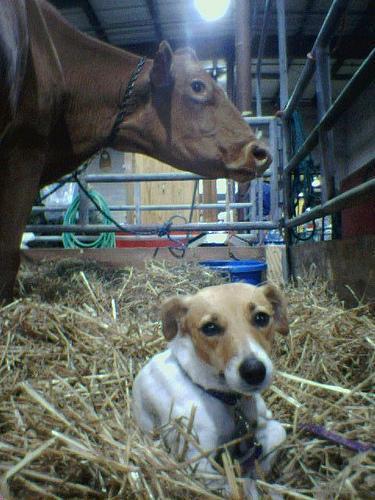How many animals are shown?
Give a very brief answer. 2. How many cats are facing away?
Give a very brief answer. 0. 